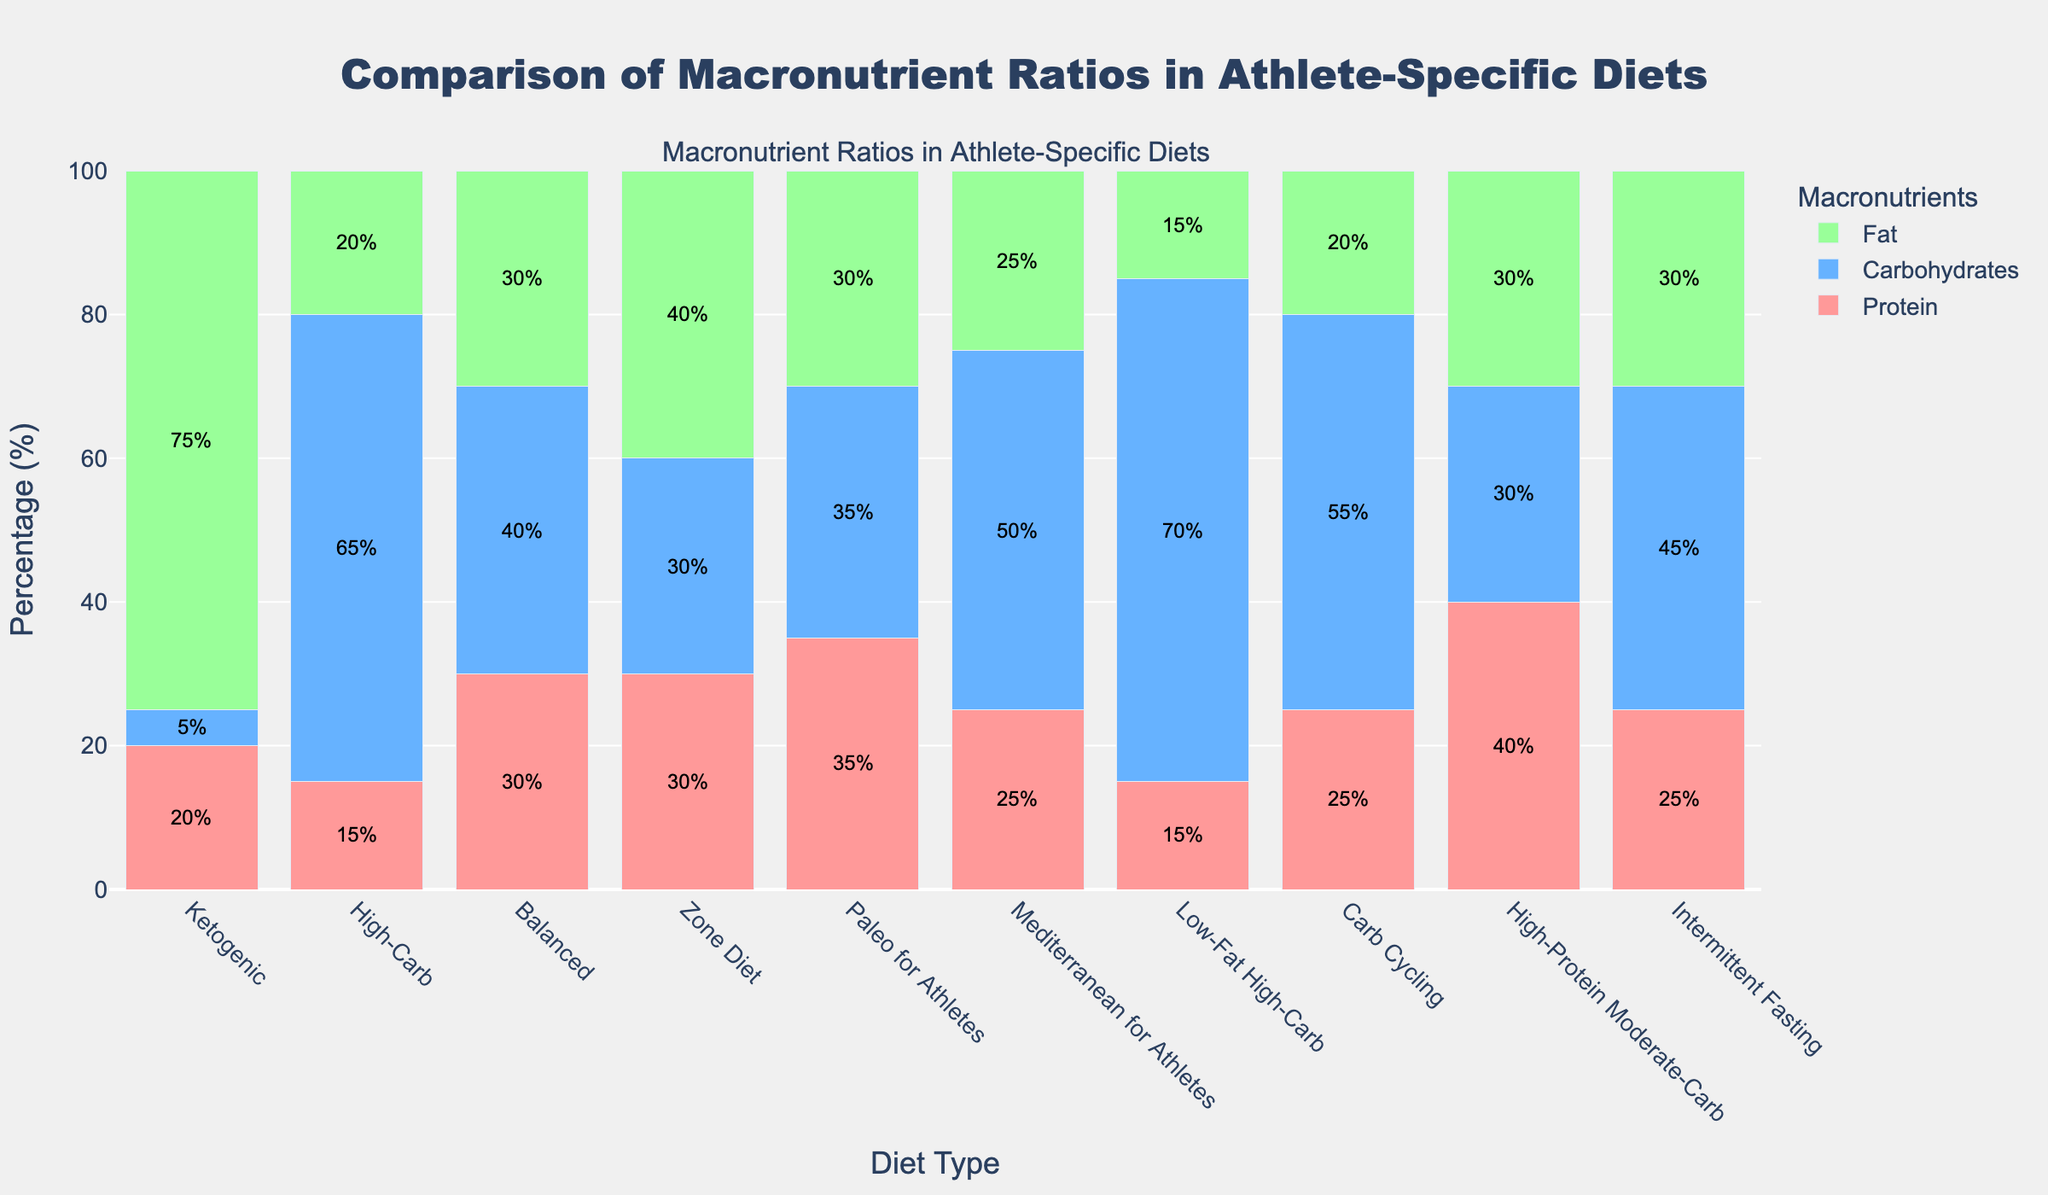What's the diet with the highest carbohydrate percentage? The diet with the highest carbohydrate percentage can be identified by looking at the tallest blue segment of the bars. The "Low-Fat High-Carb" diet has the tallest blue segment representing 70% carbohydrates.
Answer: Low-Fat High-Carb Which diet has a balanced distribution of protein, carbohydrates, and fat? A balanced macronutrient distribution implies that the percentages of protein, carbohydrates, and fat are close to each other. The "Balanced" diet, with 30% protein, 40% carbohydrates, and 30% fat, fits this description.
Answer: Balanced Between the "Ketogenic" and "Intermittent Fasting" diets, which one has a higher protein percentage? By comparing the height of the red segments representing protein, the "Intermittent Fasting" diet has a higher protein percentage (25%) compared to the "Ketogenic" diet (20%).
Answer: Intermittent Fasting How much higher is the fat percentage in the "Ketogenic" diet compared to the "High-Carb" diet? The fat percentage in the "Ketogenic" diet is 75%, and in the "High-Carb" diet, it is 20%. The difference is 75% - 20% = 55%.
Answer: 55% If you add the protein and fat percentages for the "Zone Diet," what is the total? The "Zone Diet" has 30% protein and 40% fat. Adding them together gives 30% + 40% = 70%.
Answer: 70% Which diet has the least amount of fat? The diet with the smallest green segment represents the lowest fat percentage. The "Low-Fat High-Carb" diet has the least fat at 15%.
Answer: Low-Fat High-Carb Compare the sum of protein and carbohydrate percentages in the "Mediterranean for Athletes" diet with the "Carb Cycling" diet. Which one is higher? "Mediterranean for Athletes" has 25% protein and 50% carbohydrates, summing up to 25% + 50% = 75%. "Carb Cycling" has 25% protein and 55% carbohydrates, summing up to 25% + 55% = 80%. Therefore, "Carb Cycling" is higher.
Answer: Carb Cycling Which diet type has the closest carbohydrate and fat percentages? To find the closest carbohydrate and fat percentages, look for bars where the blue and green segments are nearly equal. The "Zone Diet" has 30% carbohydrates and 40% fat, and the percentages are close.
Answer: Zone Diet On average, what is the protein percentage in the "Balanced," "Paleo for Athletes," and "High-Protein Moderate-Carb" diets? First, find the protein percentages: "Balanced" (30%), "Paleo for Athletes" (35%), and "High-Protein Moderate-Carb" (40%). The average is (30% + 35% + 40%) / 3 = 35%.
Answer: 35% 